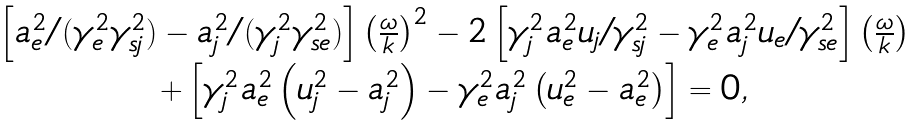<formula> <loc_0><loc_0><loc_500><loc_500>\begin{array} { c } \left [ a _ { e } ^ { 2 } / ( \gamma _ { e } ^ { 2 } \gamma _ { s j } ^ { 2 } ) - a _ { j } ^ { 2 } / ( \gamma _ { j } ^ { 2 } \gamma _ { s e } ^ { 2 } ) \right ] \left ( \frac { \omega } { k } \right ) ^ { 2 } - 2 \left [ \gamma _ { j } ^ { 2 } a _ { e } ^ { 2 } u _ { j } / \gamma _ { s j } ^ { 2 } - \gamma _ { e } ^ { 2 } a _ { j } ^ { 2 } u _ { e } / \gamma _ { s e } ^ { 2 } \right ] \left ( \frac { \omega } { k } \right ) \\ + \left [ \gamma _ { j } ^ { 2 } a _ { e } ^ { 2 } \left ( u _ { j } ^ { 2 } - a _ { j } ^ { 2 } \right ) - \gamma _ { e } ^ { 2 } a _ { j } ^ { 2 } \left ( u _ { e } ^ { 2 } - a _ { e } ^ { 2 } \right ) \right ] = 0 , \end{array}</formula> 